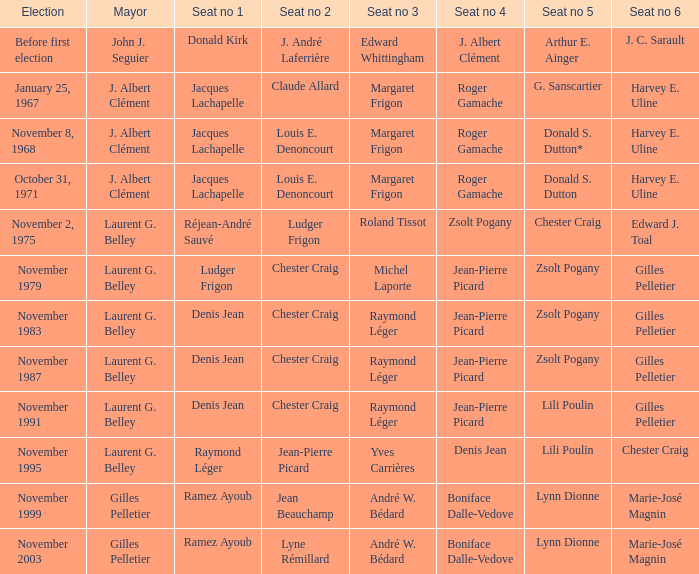While john j. seguier served as mayor, who held the first seat? Donald Kirk. 